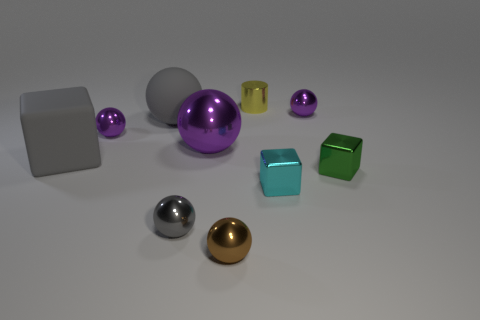There is a green object; does it have the same shape as the gray object behind the large purple thing?
Your answer should be compact. No. What is the color of the big ball that is the same material as the tiny yellow cylinder?
Provide a succinct answer. Purple. How big is the gray rubber object that is in front of the big metallic object?
Provide a succinct answer. Large. Are there fewer purple spheres that are behind the brown metallic thing than green things?
Give a very brief answer. No. Do the big cube and the rubber ball have the same color?
Make the answer very short. Yes. Is there any other thing that is the same shape as the small green object?
Keep it short and to the point. Yes. Is the number of tiny gray things less than the number of purple balls?
Ensure brevity in your answer.  Yes. There is a rubber block that is in front of the tiny purple metallic sphere that is right of the brown object; what is its color?
Provide a short and direct response. Gray. The big purple object that is in front of the big ball that is on the left side of the gray sphere in front of the small green thing is made of what material?
Keep it short and to the point. Metal. Is the size of the metallic cube that is on the left side of the green shiny thing the same as the green shiny object?
Offer a very short reply. Yes. 